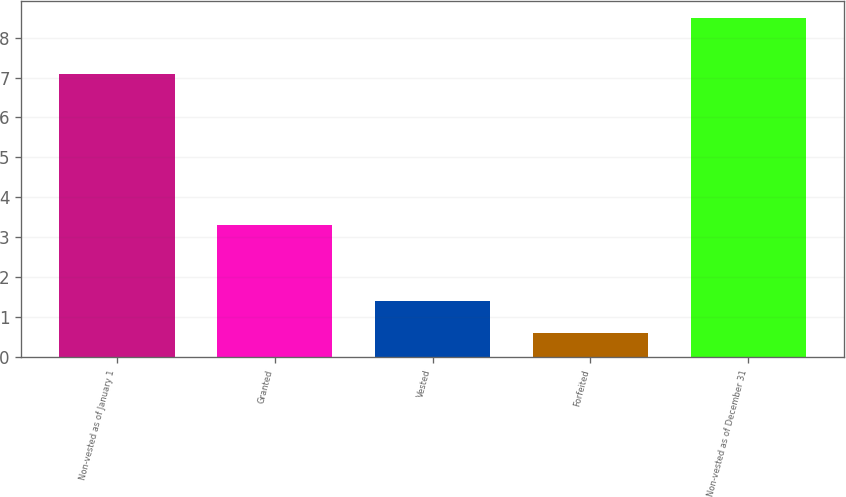Convert chart to OTSL. <chart><loc_0><loc_0><loc_500><loc_500><bar_chart><fcel>Non-vested as of January 1<fcel>Granted<fcel>Vested<fcel>Forfeited<fcel>Non-vested as of December 31<nl><fcel>7.1<fcel>3.3<fcel>1.39<fcel>0.6<fcel>8.5<nl></chart> 